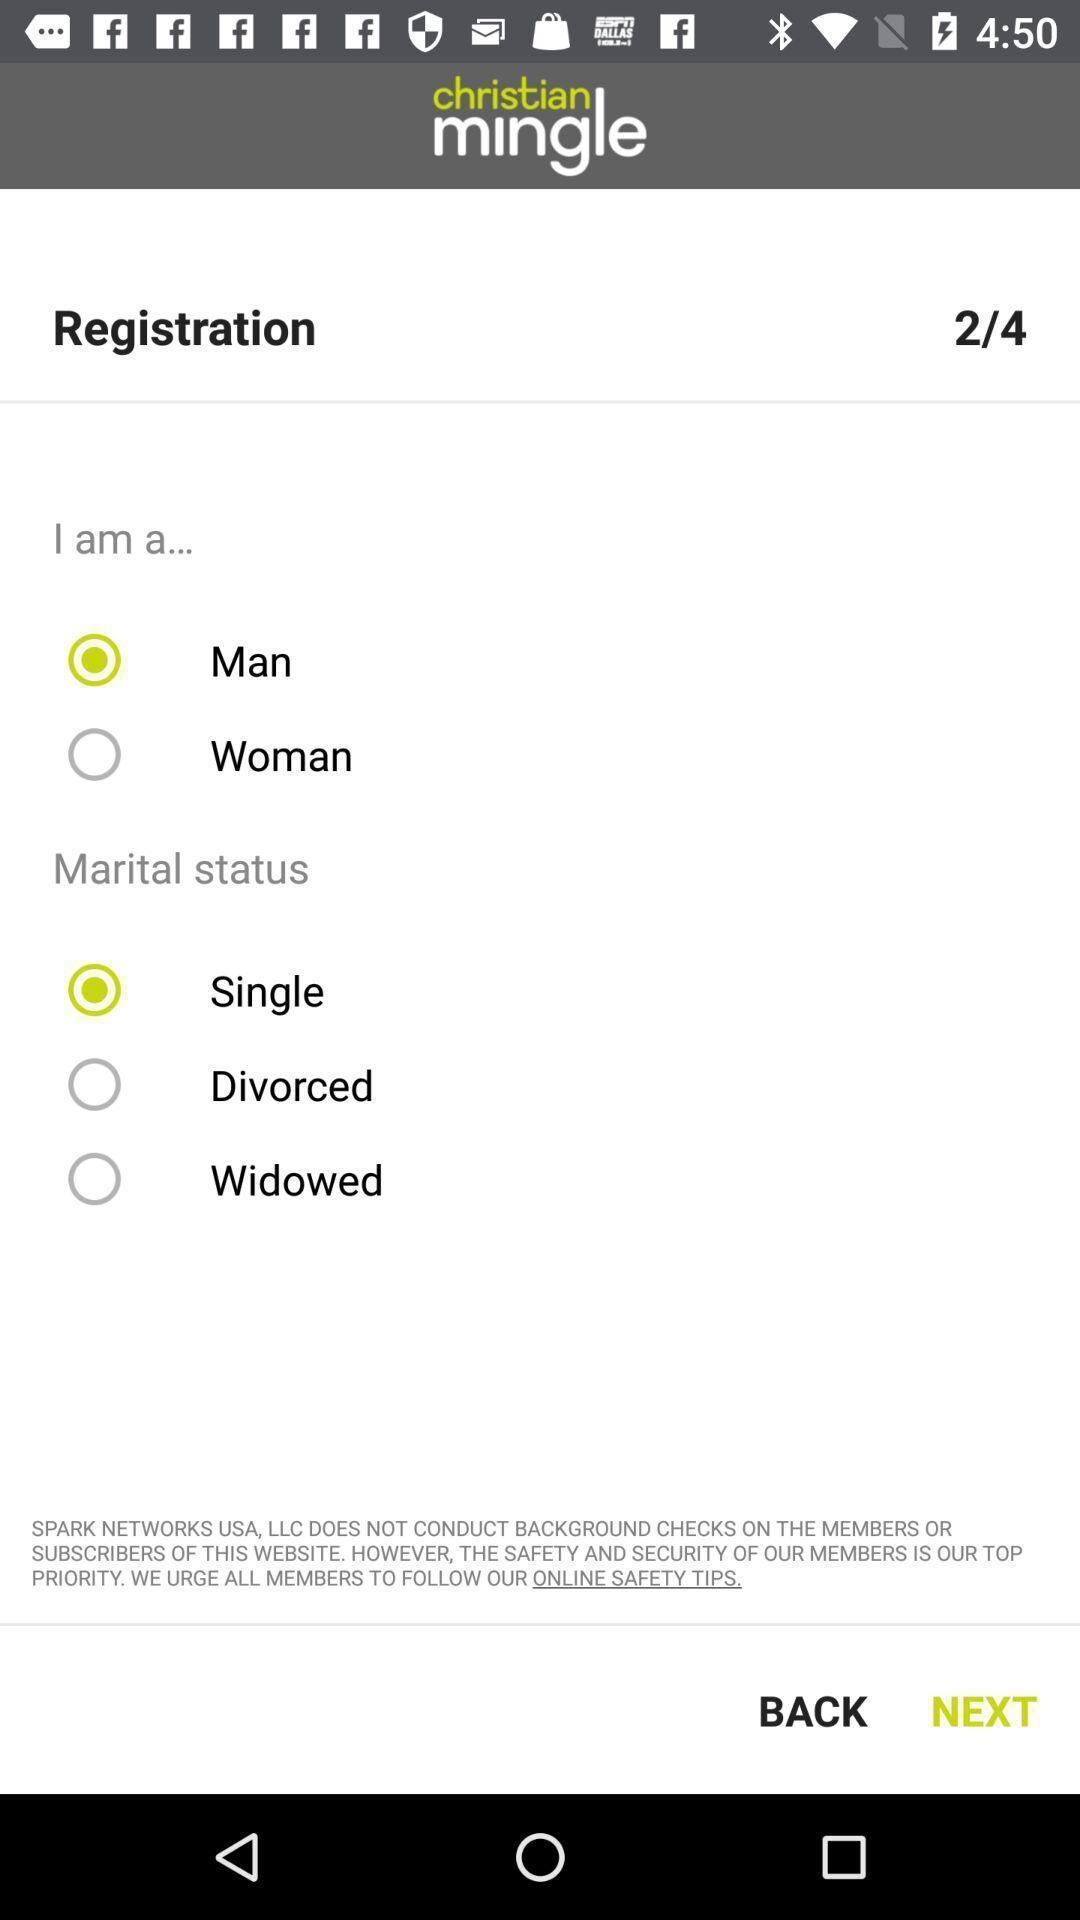Provide a textual representation of this image. Second page of the registration is displaying. 